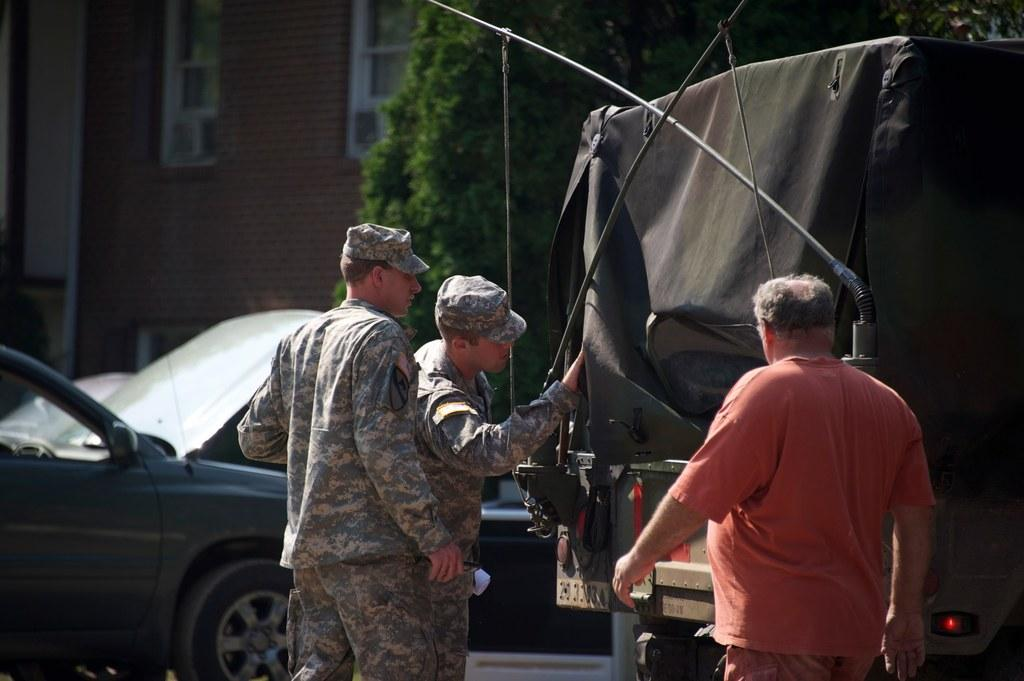How many people are present in the image? There are three persons standing in the image. What else can be seen in the image besides the people? There are vehicles, trees, and a building with windows in the image. Are there any apples being driven in the image? There are no apples or driving depicted in the image. What type of destruction can be seen in the image? There is no destruction present in the image; it features people, vehicles, trees, and a building with windows. 